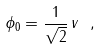<formula> <loc_0><loc_0><loc_500><loc_500>\phi _ { 0 } = \frac { 1 } { \sqrt { 2 } } \, v \ ,</formula> 